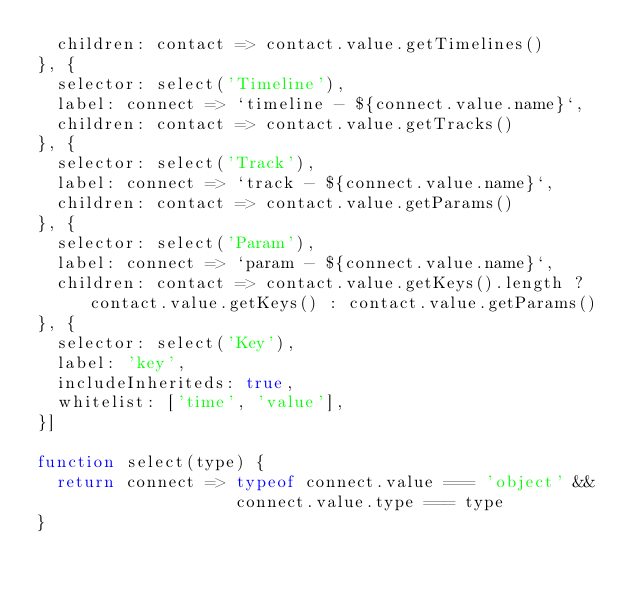Convert code to text. <code><loc_0><loc_0><loc_500><loc_500><_JavaScript_>  children: contact => contact.value.getTimelines()
}, {
  selector: select('Timeline'),
  label: connect => `timeline - ${connect.value.name}`,
  children: contact => contact.value.getTracks()
}, {
  selector: select('Track'),
  label: connect => `track - ${connect.value.name}`,
  children: contact => contact.value.getParams()
}, {
  selector: select('Param'),
  label: connect => `param - ${connect.value.name}`,
  children: contact => contact.value.getKeys().length ? contact.value.getKeys() : contact.value.getParams()
}, {
  selector: select('Key'),
  label: 'key',
  includeInheriteds: true,
  whitelist: ['time', 'value'],
}]

function select(type) {
  return connect => typeof connect.value === 'object' &&
                    connect.value.type === type
}
</code> 